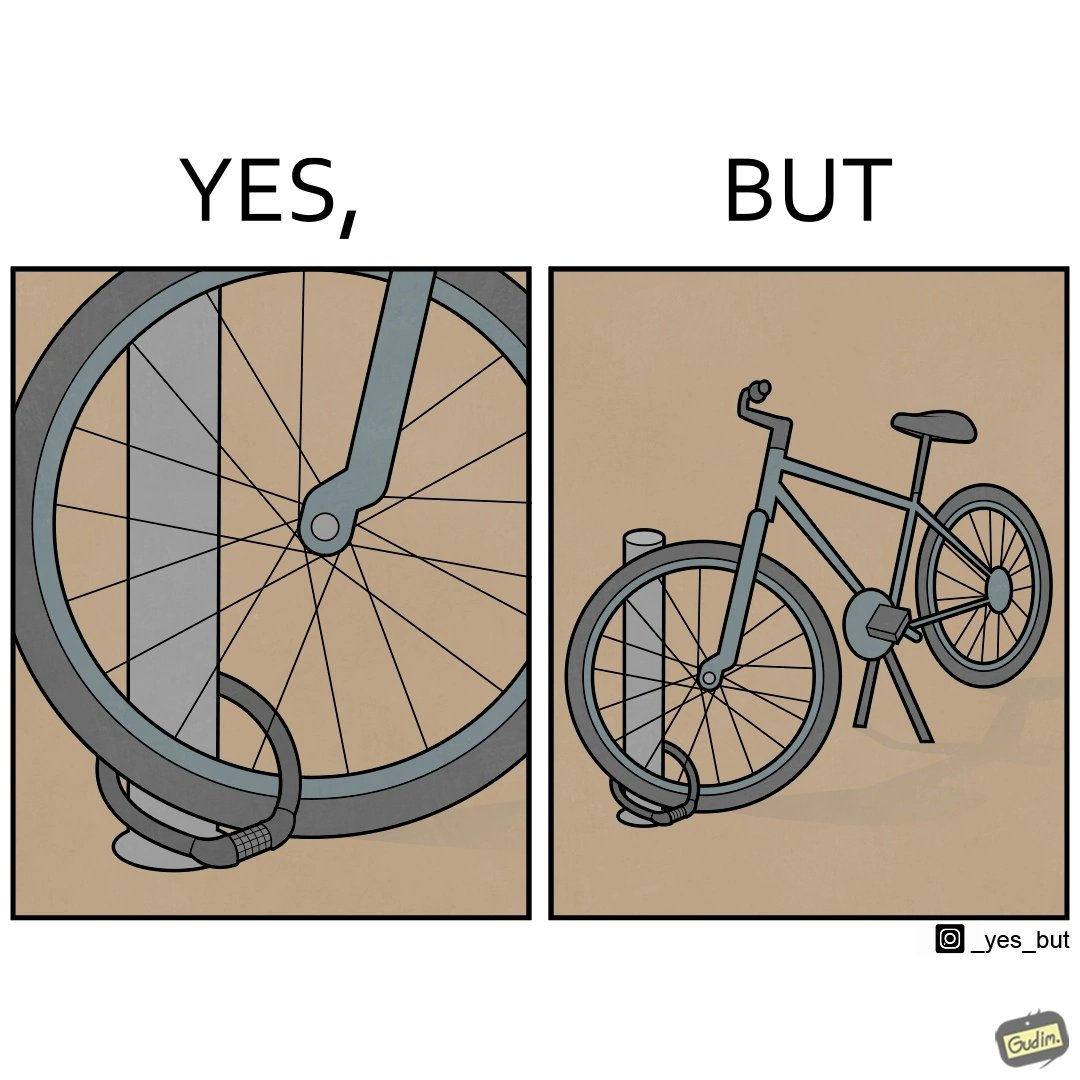Describe what you see in this image. the irony is that people lock their bikes on poles where anyone can just lift the bike out of the pole 